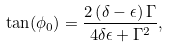Convert formula to latex. <formula><loc_0><loc_0><loc_500><loc_500>\tan ( \phi _ { 0 } ) = \frac { 2 \left ( \delta - \epsilon \right ) \Gamma } { 4 \delta \epsilon + \Gamma ^ { 2 } } ,</formula> 